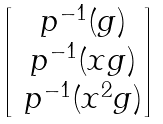<formula> <loc_0><loc_0><loc_500><loc_500>\begin{bmatrix} \ p ^ { - 1 } ( g ) \\ \ p ^ { - 1 } ( x g ) \\ \ p ^ { - 1 } ( x ^ { 2 } g ) \end{bmatrix}</formula> 